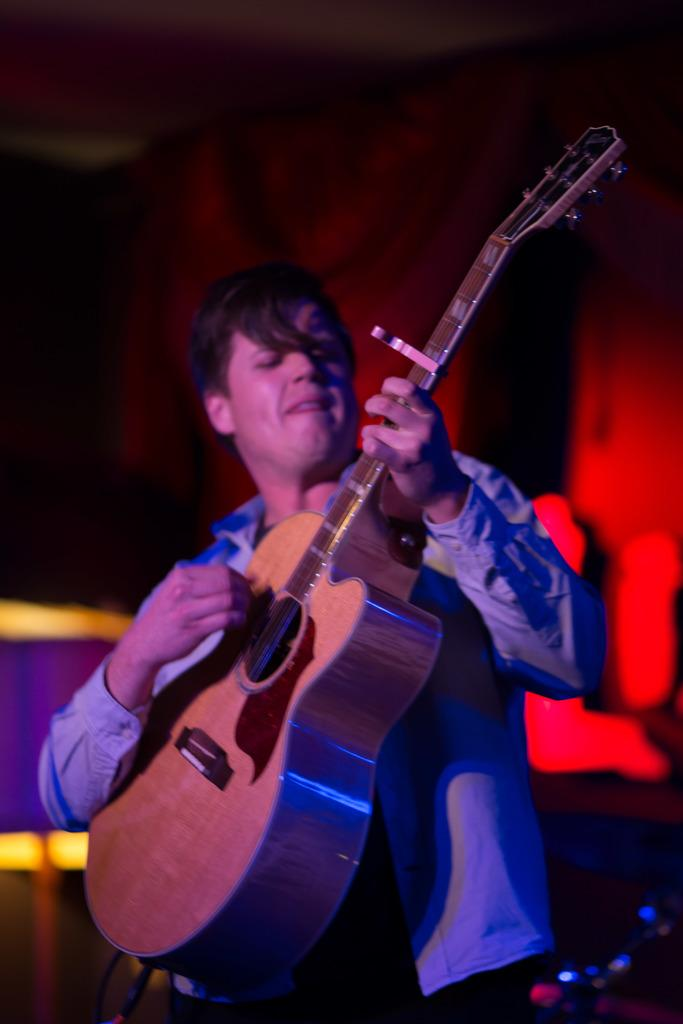What is the person in the image doing? The person is playing the guitar. What color is the background of the image? The background of the image is red. What color is the person's shirt? The person is wearing a blue shirt. What color are the person's pants? The person is wearing blue pants. How many nets can be seen in the image? There are no nets present in the image. What type of pin is being used by the person in the image? There is no pin visible in the image; the person is playing the guitar. 